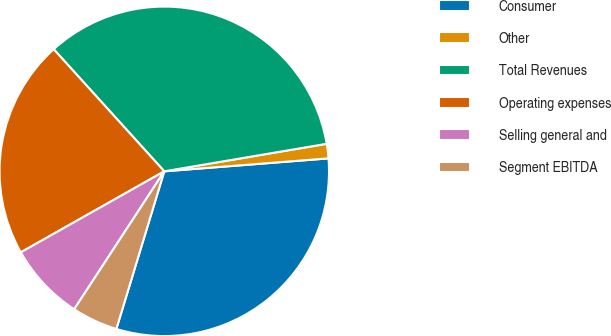Convert chart. <chart><loc_0><loc_0><loc_500><loc_500><pie_chart><fcel>Consumer<fcel>Other<fcel>Total Revenues<fcel>Operating expenses<fcel>Selling general and<fcel>Segment EBITDA<nl><fcel>30.95%<fcel>1.42%<fcel>34.04%<fcel>21.47%<fcel>7.61%<fcel>4.51%<nl></chart> 